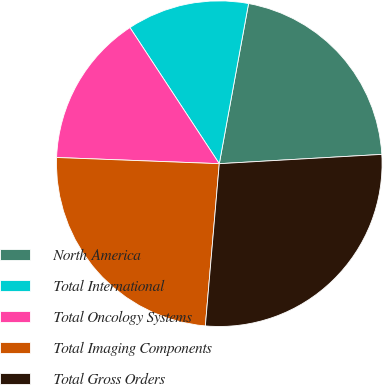Convert chart. <chart><loc_0><loc_0><loc_500><loc_500><pie_chart><fcel>North America<fcel>Total International<fcel>Total Oncology Systems<fcel>Total Imaging Components<fcel>Total Gross Orders<nl><fcel>21.21%<fcel>12.12%<fcel>15.15%<fcel>24.24%<fcel>27.27%<nl></chart> 